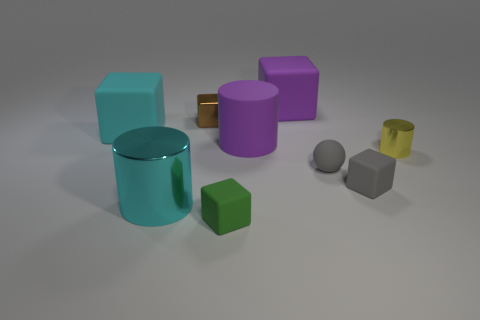What number of cubes are the same color as the rubber ball?
Offer a very short reply. 1. Is the big cyan metal thing the same shape as the brown thing?
Keep it short and to the point. No. What shape is the tiny metal thing behind the large block in front of the tiny brown block?
Your response must be concise. Cube. Is the size of the cyan cube the same as the metal cylinder that is behind the cyan cylinder?
Offer a terse response. No. How big is the gray object that is behind the tiny block that is right of the matte block that is in front of the large cyan cylinder?
Your response must be concise. Small. What number of things are things that are on the left side of the purple cylinder or rubber blocks?
Your response must be concise. 6. There is a purple matte object that is in front of the purple matte block; what number of large cyan rubber blocks are to the right of it?
Keep it short and to the point. 0. Is the number of things in front of the tiny yellow object greater than the number of tiny metal objects?
Give a very brief answer. Yes. There is a thing that is to the right of the big cyan cube and left of the small brown metal cube; what size is it?
Give a very brief answer. Large. The tiny thing that is in front of the tiny yellow shiny cylinder and right of the small gray matte sphere has what shape?
Provide a short and direct response. Cube. 